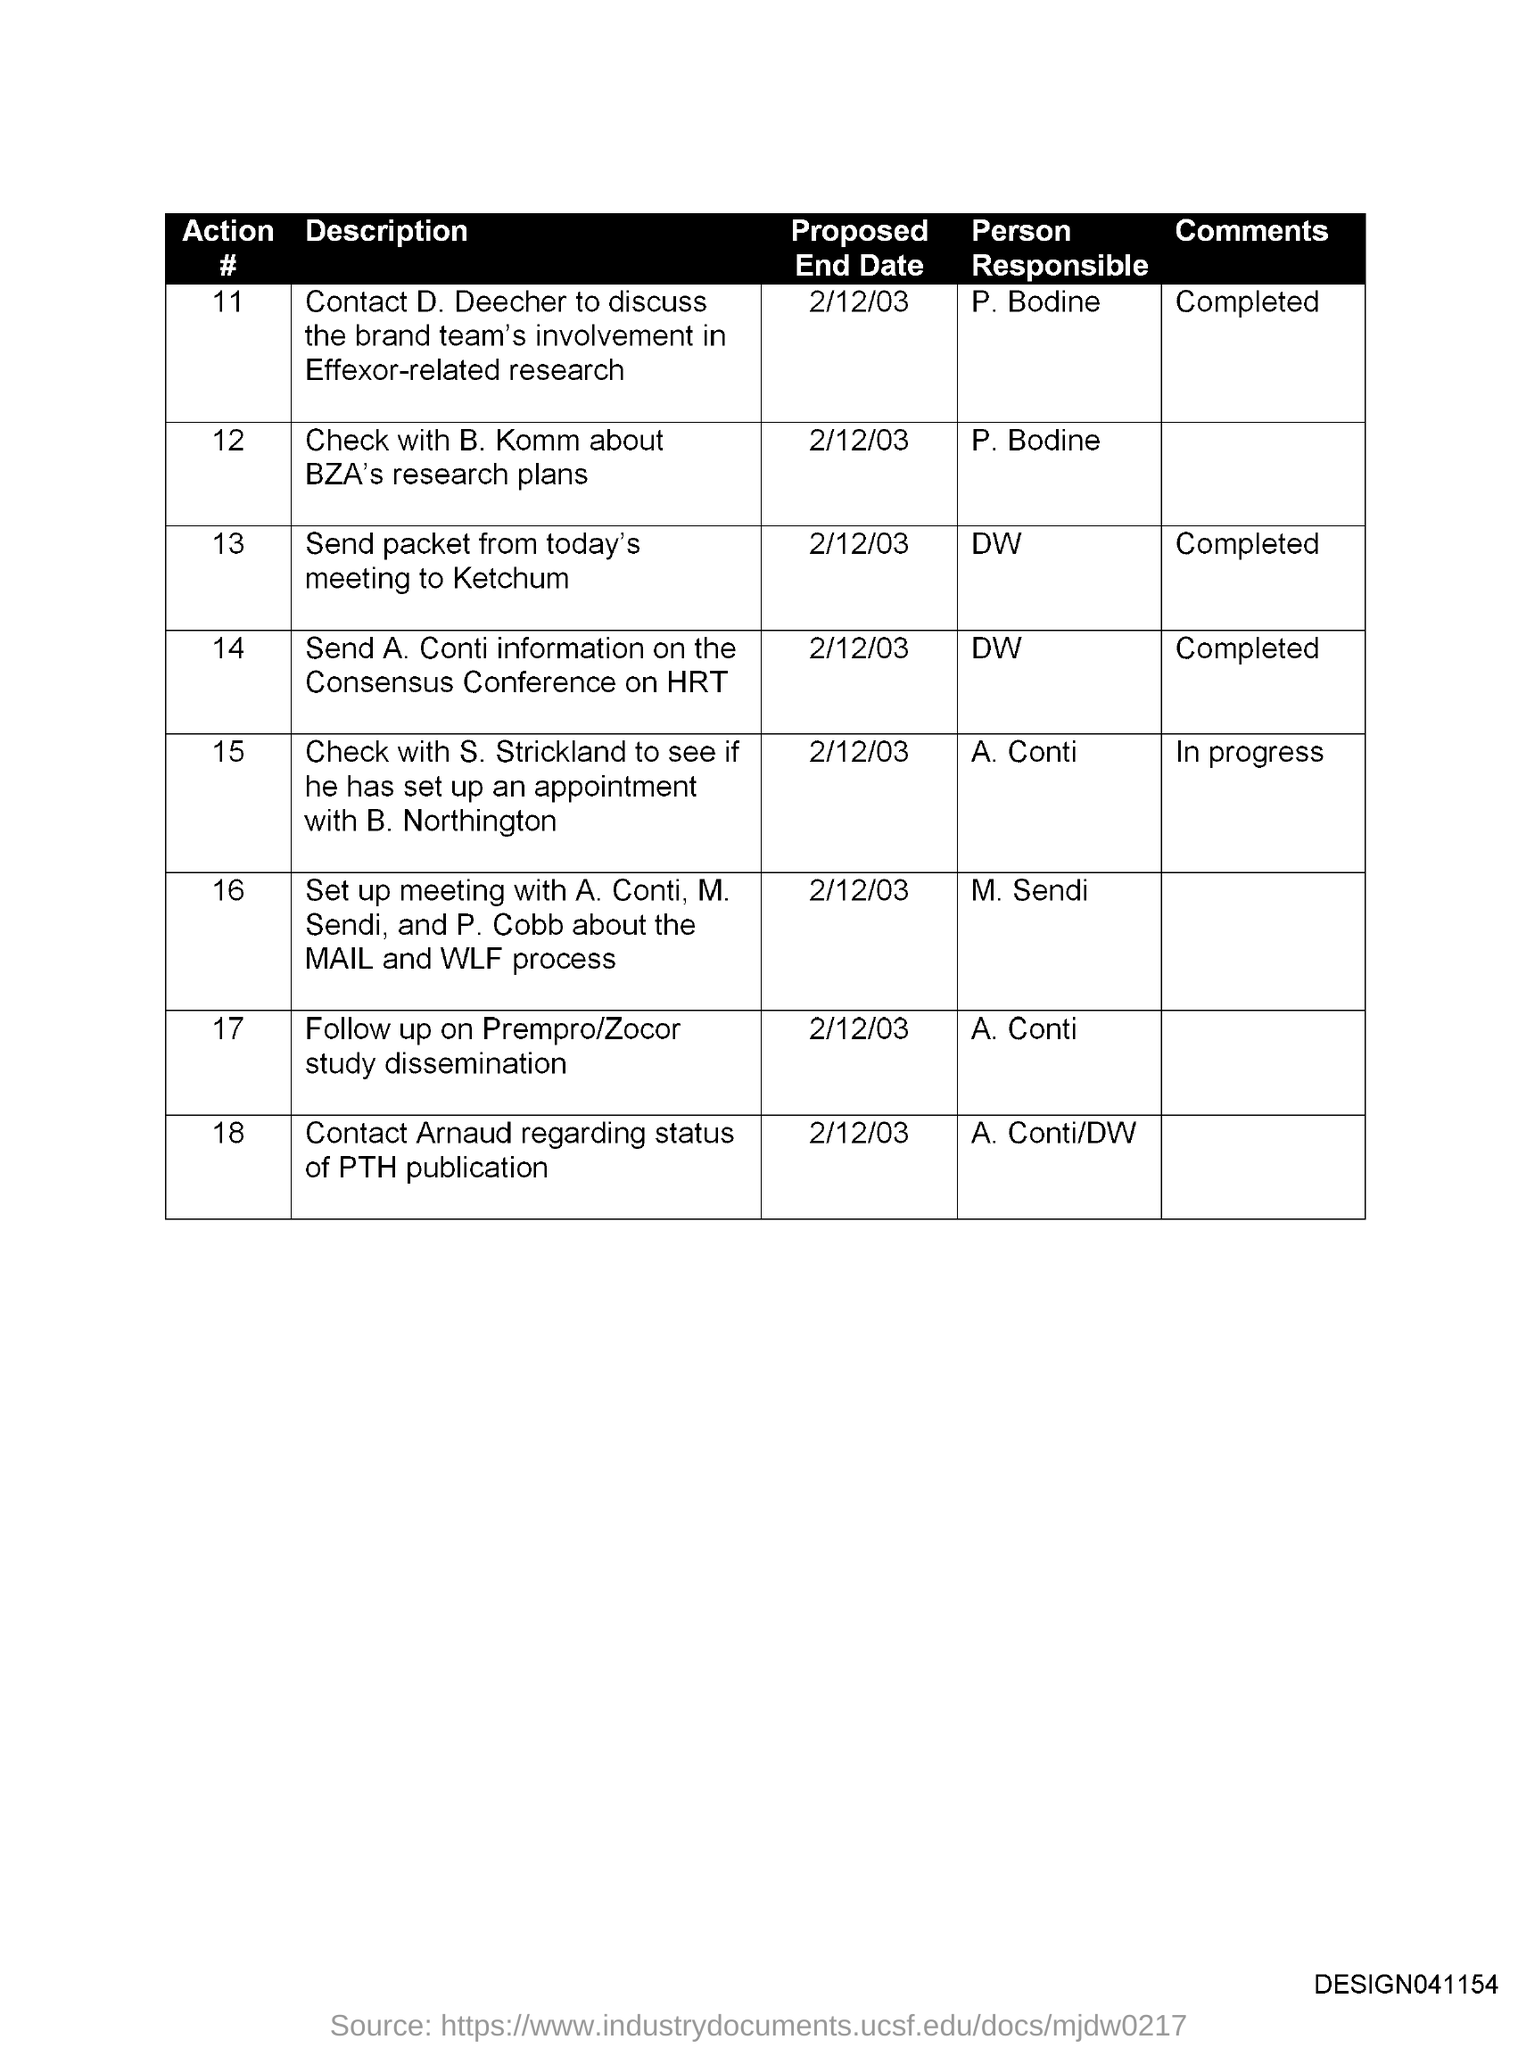Point out several critical features in this image. The person responsible for sending the packet from today's meeting to Ketchum is unknown. The person responsible for contacting Arnaud regarding the status of the PTH publication is Conti/DW. It is necessary to contact P. Bodine to obtain information about BZA's research plans, as they are responsible for communicating with B. Komm regarding these matters. It is proposed to check with B. Komm regarding the research plans of the BZA by the end date of February 12, 2003. The proposed end date to follow up on the dissemination of the Prempro/Zocor study is 2/12/03. 